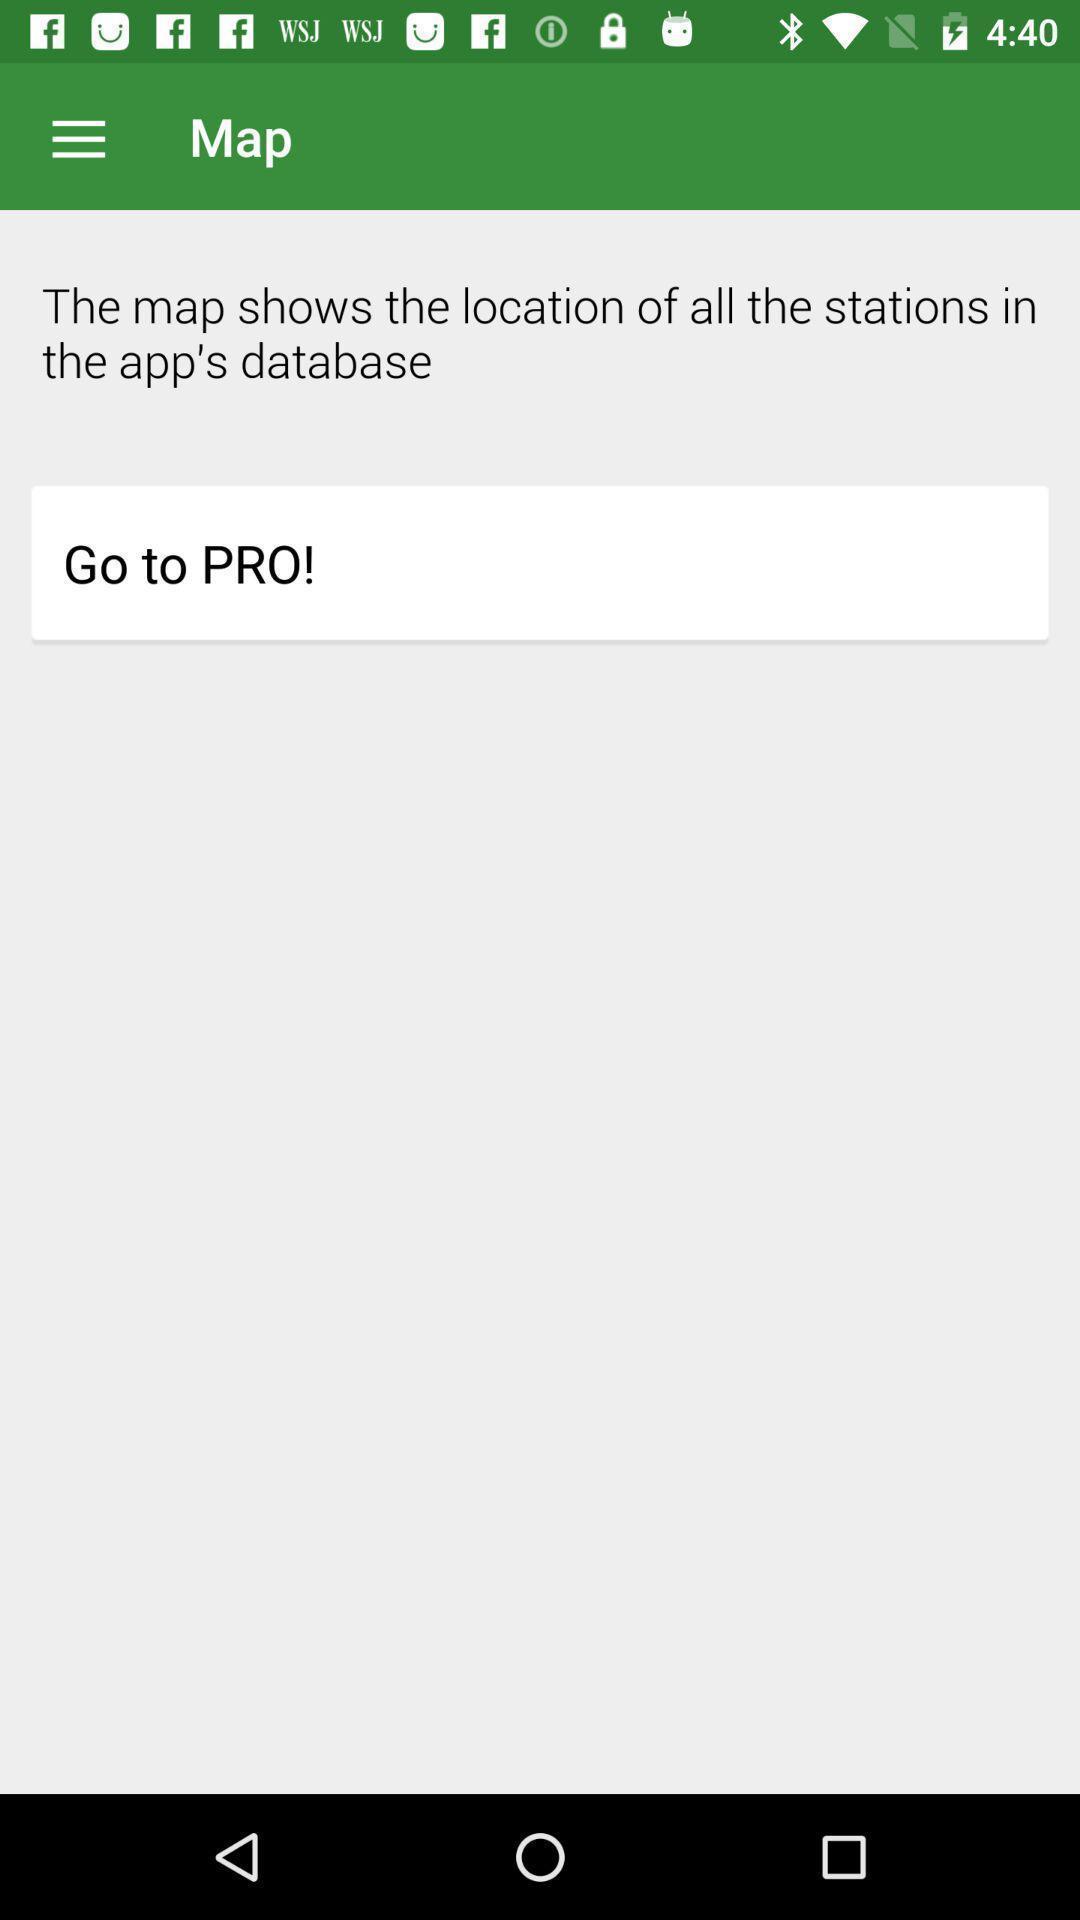Give me a summary of this screen capture. Page showing train tickets available. 